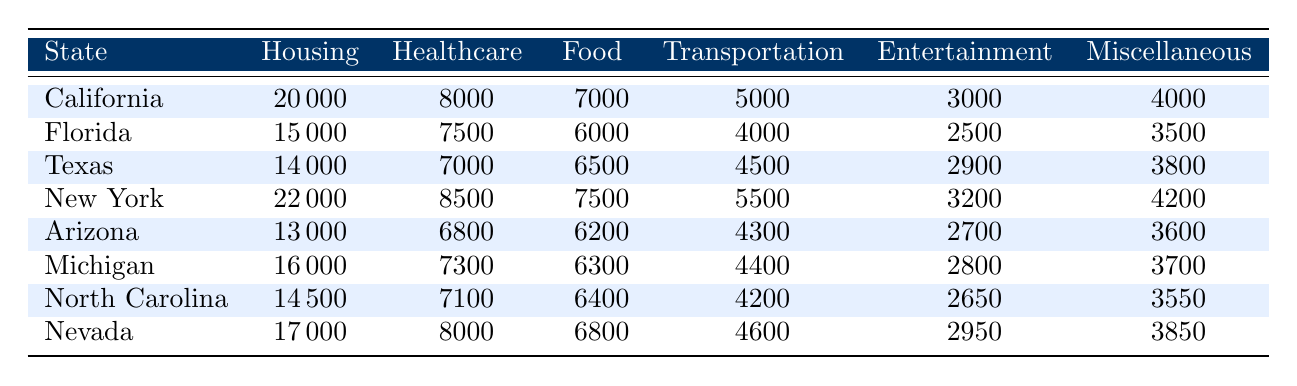What state has the highest expenditure on housing? By examining the 'Housing' column, I see that New York has the highest value at 22000. No other state exceeds this amount.
Answer: New York What is the total expenditure on healthcare in Florida and Texas combined? To find the combined healthcare expenditure, I add Florida's (7500) and Texas's (7000) values: 7500 + 7000 = 14500.
Answer: 14500 Is the healthcare expenditure in Nevada greater than the average healthcare expenditure across all states? The average is calculated as follows: First, I will sum the healthcare expenditures: 8000 (California) + 7500 (Florida) + 7000 (Texas) + 8500 (New York) + 6800 (Arizona) + 7300 (Michigan) + 7100 (North Carolina) + 8000 (Nevada) = 55,200. Next, divide by 8 (the number of states) to find the average: 55,200 / 8 = 6900. Since Nevada's healthcare expenditure is 8000, which is greater than 6900, the answer is yes.
Answer: Yes Which state spends the least on entertainment, and what is the amount? Looking at the 'Entertainment' column, North Carolina shows the least expenditure of 2650.
Answer: North Carolina; 2650 How much more does California spend on housing than Arizona? California's housing expenditure is 20000, while Arizona's is 13000. The difference is calculated as 20000 - 13000 = 7000.
Answer: 7000 Are the total expenditures on food and transportation in Michigan less than those in New York? For Michigan, food is 6300 and transportation is 4400, totaling 6300 + 4400 = 10700. For New York, food is 7500 and transportation is 5500, totaling 7500 + 5500 = 13000. Comparing, 10700 is indeed less than 13000.
Answer: Yes What is the median expenditure on housing across the states? I will arrange the housing expenditures in ascending order: 13000 (Arizona), 14000 (Texas), 14500 (North Carolina), 15000 (Florida), 16000 (Michigan), 17000 (Nevada), 20000 (California), 22000 (New York). The middle values (Florida and Michigan) are 15000 and 16000. The median is (15000 + 16000) / 2 = 15500.
Answer: 15500 